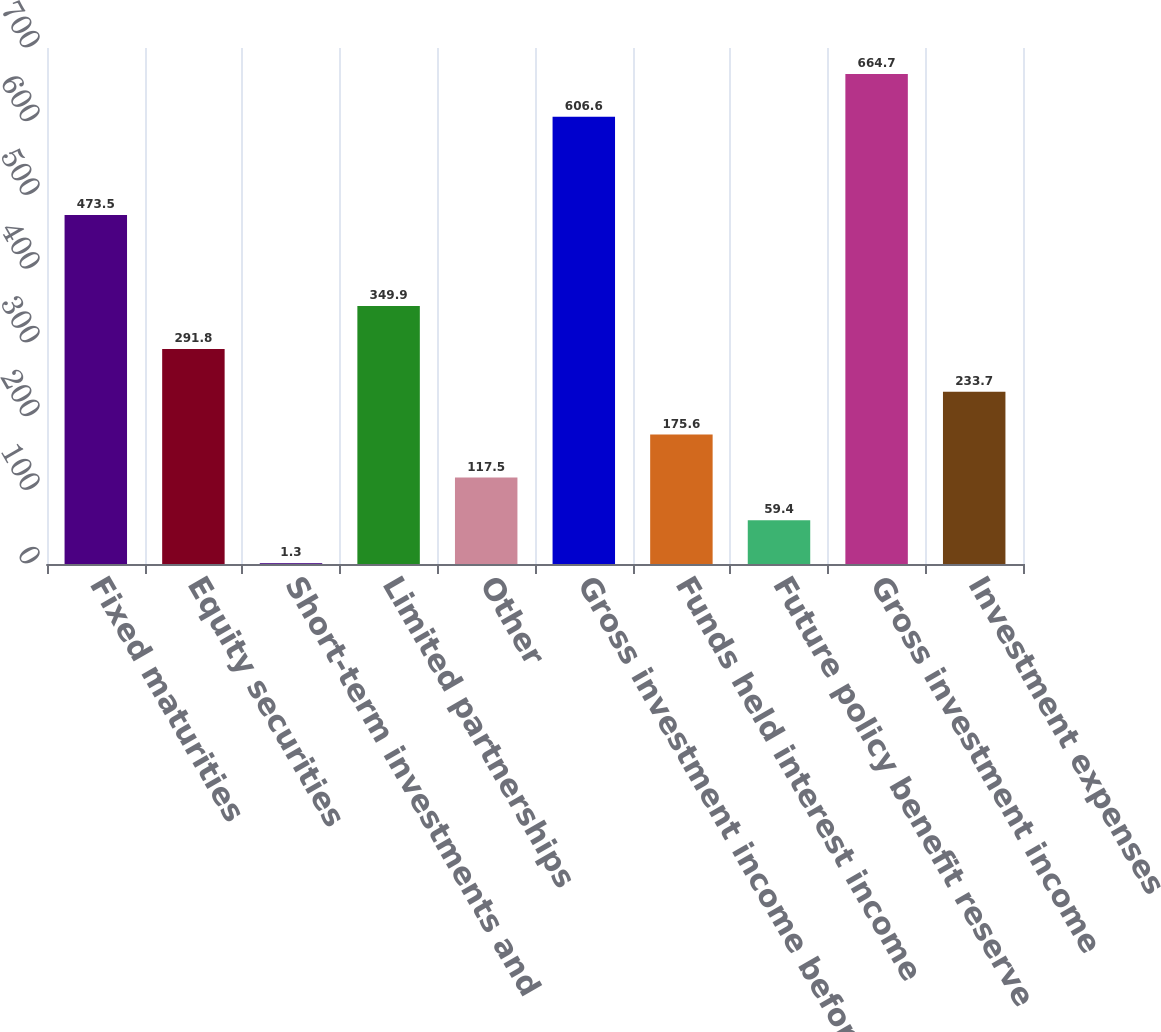Convert chart to OTSL. <chart><loc_0><loc_0><loc_500><loc_500><bar_chart><fcel>Fixed maturities<fcel>Equity securities<fcel>Short-term investments and<fcel>Limited partnerships<fcel>Other<fcel>Gross investment income before<fcel>Funds held interest income<fcel>Future policy benefit reserve<fcel>Gross investment income<fcel>Investment expenses<nl><fcel>473.5<fcel>291.8<fcel>1.3<fcel>349.9<fcel>117.5<fcel>606.6<fcel>175.6<fcel>59.4<fcel>664.7<fcel>233.7<nl></chart> 